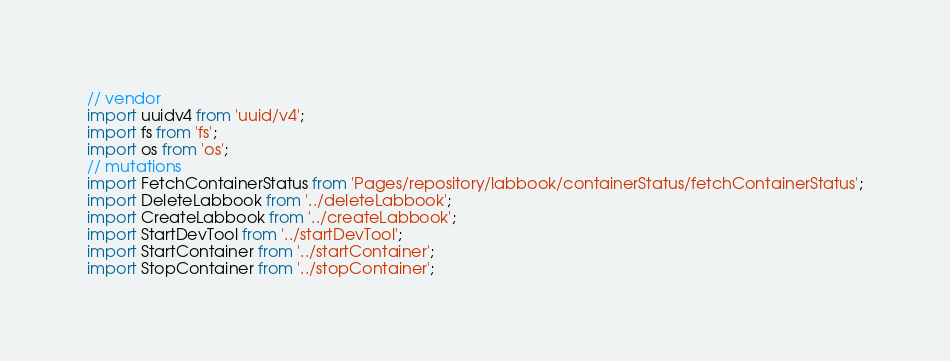Convert code to text. <code><loc_0><loc_0><loc_500><loc_500><_JavaScript_>// vendor
import uuidv4 from 'uuid/v4';
import fs from 'fs';
import os from 'os';
// mutations
import FetchContainerStatus from 'Pages/repository/labbook/containerStatus/fetchContainerStatus';
import DeleteLabbook from '../deleteLabbook';
import CreateLabbook from '../createLabbook';
import StartDevTool from '../startDevTool';
import StartContainer from '../startContainer';
import StopContainer from '../stopContainer';</code> 